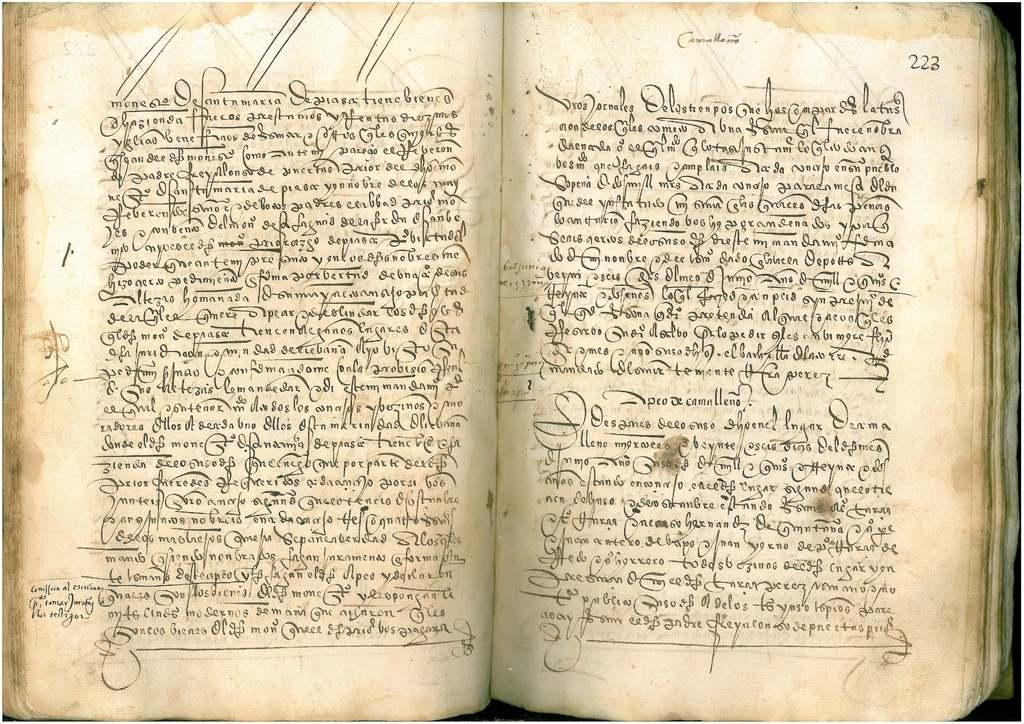What page has a title?
Make the answer very short. 223. Is that 222 on the top right hand corner of the book?
Your answer should be compact. Yes. 